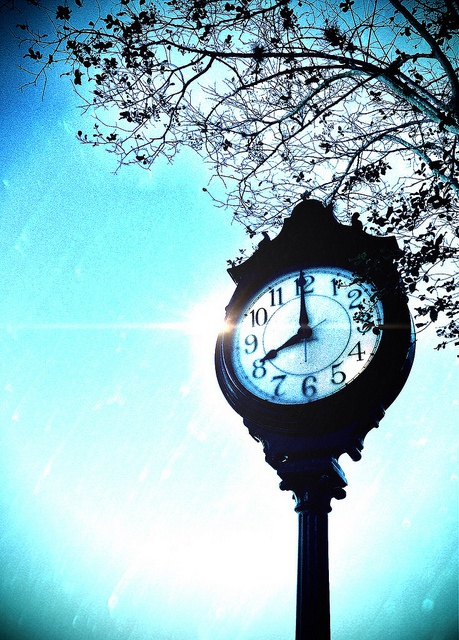Describe the objects in this image and their specific colors. I can see a clock in black, white, and lightblue tones in this image. 